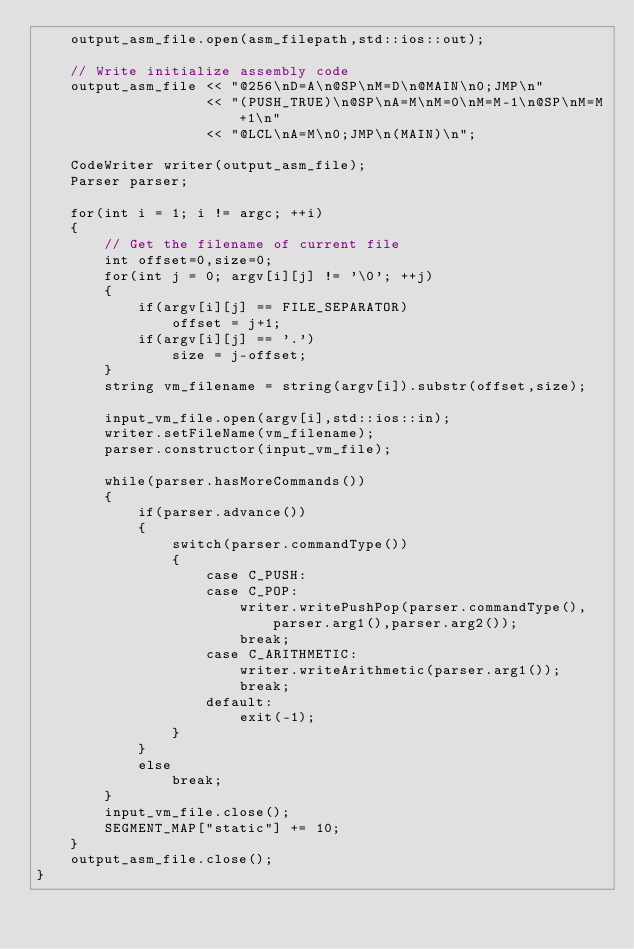Convert code to text. <code><loc_0><loc_0><loc_500><loc_500><_C++_>    output_asm_file.open(asm_filepath,std::ios::out);

    // Write initialize assembly code
    output_asm_file << "@256\nD=A\n@SP\nM=D\n@MAIN\n0;JMP\n"
                    << "(PUSH_TRUE)\n@SP\nA=M\nM=0\nM=M-1\n@SP\nM=M+1\n"
                    << "@LCL\nA=M\n0;JMP\n(MAIN)\n";

    CodeWriter writer(output_asm_file);
    Parser parser;

    for(int i = 1; i != argc; ++i)
    {
        // Get the filename of current file
        int offset=0,size=0;
        for(int j = 0; argv[i][j] != '\0'; ++j)
        {
            if(argv[i][j] == FILE_SEPARATOR)
                offset = j+1;
            if(argv[i][j] == '.')
                size = j-offset;
        }
        string vm_filename = string(argv[i]).substr(offset,size);

        input_vm_file.open(argv[i],std::ios::in);
        writer.setFileName(vm_filename);
        parser.constructor(input_vm_file);

        while(parser.hasMoreCommands())
        {
            if(parser.advance())
            {
                switch(parser.commandType())
                {
                    case C_PUSH:
                    case C_POP:
                        writer.writePushPop(parser.commandType(),parser.arg1(),parser.arg2());
                        break;
                    case C_ARITHMETIC:
                        writer.writeArithmetic(parser.arg1());
                        break;
                    default:
                        exit(-1);
                }
            }
            else
                break;
        }
        input_vm_file.close();
        SEGMENT_MAP["static"] += 10;
    }
    output_asm_file.close();
}</code> 